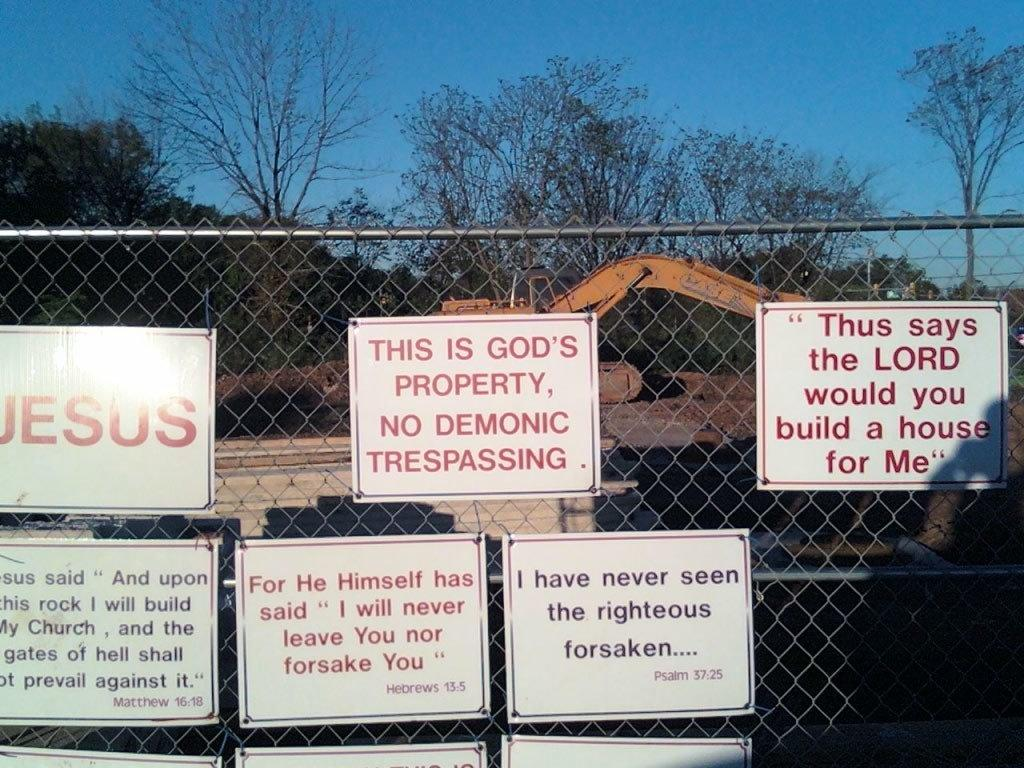<image>
Present a compact description of the photo's key features. a construction yard with signs about god and Jesus around it 